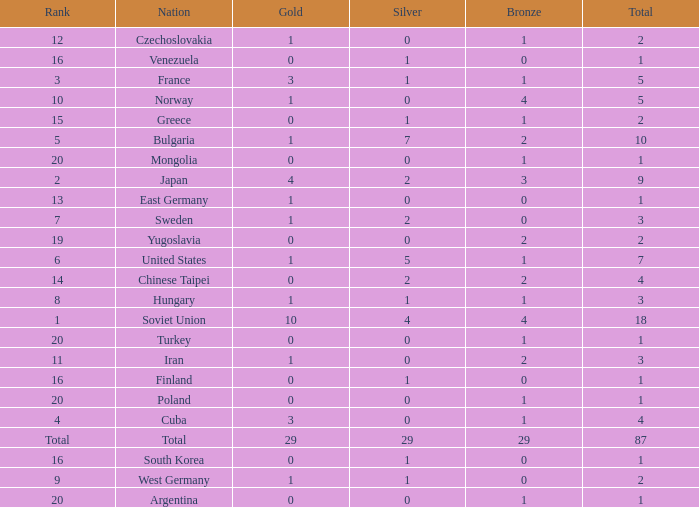What is the sum of gold medals for a rank of 14? 0.0. 